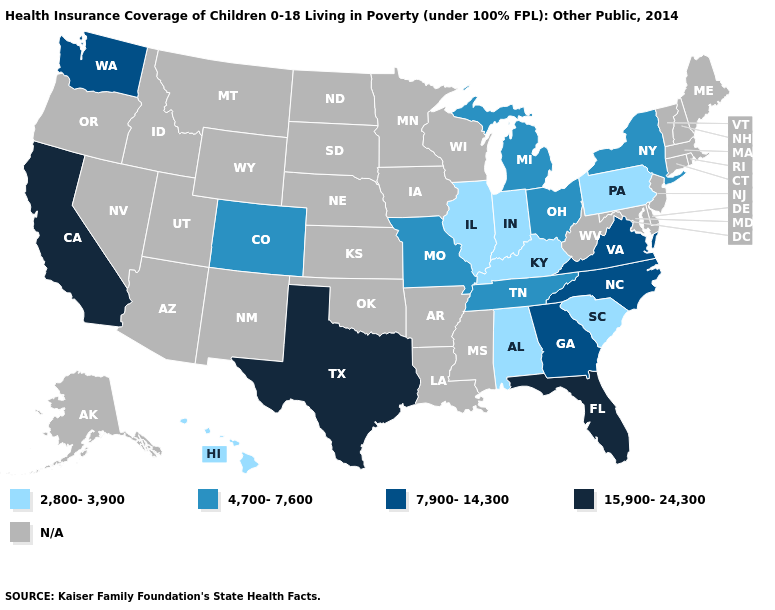Does the map have missing data?
Be succinct. Yes. Name the states that have a value in the range 7,900-14,300?
Give a very brief answer. Georgia, North Carolina, Virginia, Washington. Name the states that have a value in the range 7,900-14,300?
Give a very brief answer. Georgia, North Carolina, Virginia, Washington. What is the lowest value in the MidWest?
Answer briefly. 2,800-3,900. What is the highest value in the USA?
Concise answer only. 15,900-24,300. What is the value of Hawaii?
Give a very brief answer. 2,800-3,900. Does the first symbol in the legend represent the smallest category?
Concise answer only. Yes. Does California have the lowest value in the USA?
Short answer required. No. Name the states that have a value in the range 4,700-7,600?
Concise answer only. Colorado, Michigan, Missouri, New York, Ohio, Tennessee. What is the lowest value in the South?
Quick response, please. 2,800-3,900. What is the highest value in the USA?
Be succinct. 15,900-24,300. Does Michigan have the highest value in the MidWest?
Quick response, please. Yes. Which states have the highest value in the USA?
Quick response, please. California, Florida, Texas. Name the states that have a value in the range N/A?
Give a very brief answer. Alaska, Arizona, Arkansas, Connecticut, Delaware, Idaho, Iowa, Kansas, Louisiana, Maine, Maryland, Massachusetts, Minnesota, Mississippi, Montana, Nebraska, Nevada, New Hampshire, New Jersey, New Mexico, North Dakota, Oklahoma, Oregon, Rhode Island, South Dakota, Utah, Vermont, West Virginia, Wisconsin, Wyoming. What is the value of North Dakota?
Answer briefly. N/A. 